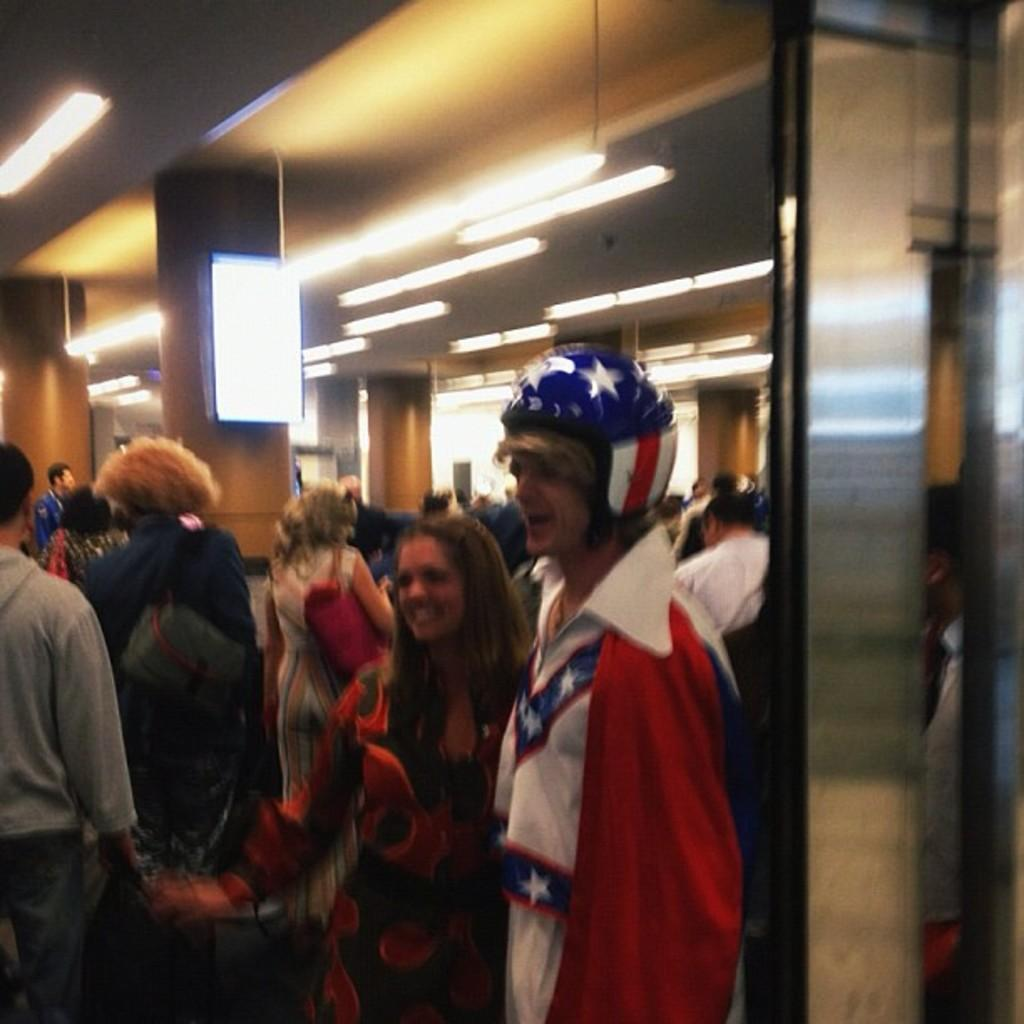Where is the location of the image? The image is inside a building. What types of people are present in the building? There are men and women in the building. Can you describe a specific feature of the building? There is a display board on a pillar in the building. What is the source of light in the building? There are lights on the ceiling in the building. What type of learning is taking place in the image? There is no indication of any learning taking place in the image. Can you see a wrench being used by anyone in the image? There is no wrench present in the image. 